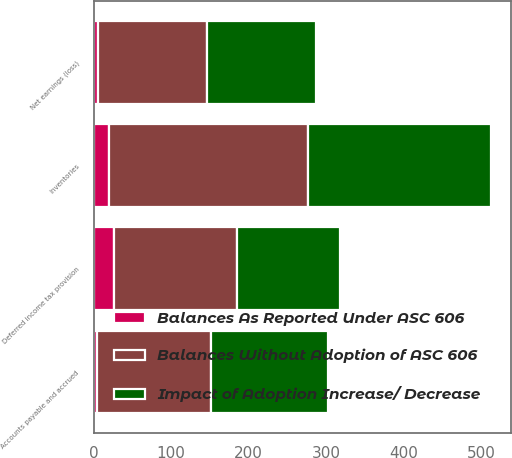Convert chart to OTSL. <chart><loc_0><loc_0><loc_500><loc_500><stacked_bar_chart><ecel><fcel>Net earnings (loss)<fcel>Deferred income tax provision<fcel>Inventories<fcel>Accounts payable and accrued<nl><fcel>Impact of Adoption Increase/ Decrease<fcel>140<fcel>133<fcel>236<fcel>151<nl><fcel>Balances Without Adoption of ASC 606<fcel>140<fcel>159<fcel>256<fcel>147<nl><fcel>Balances As Reported Under ASC 606<fcel>6<fcel>26<fcel>20<fcel>4<nl></chart> 